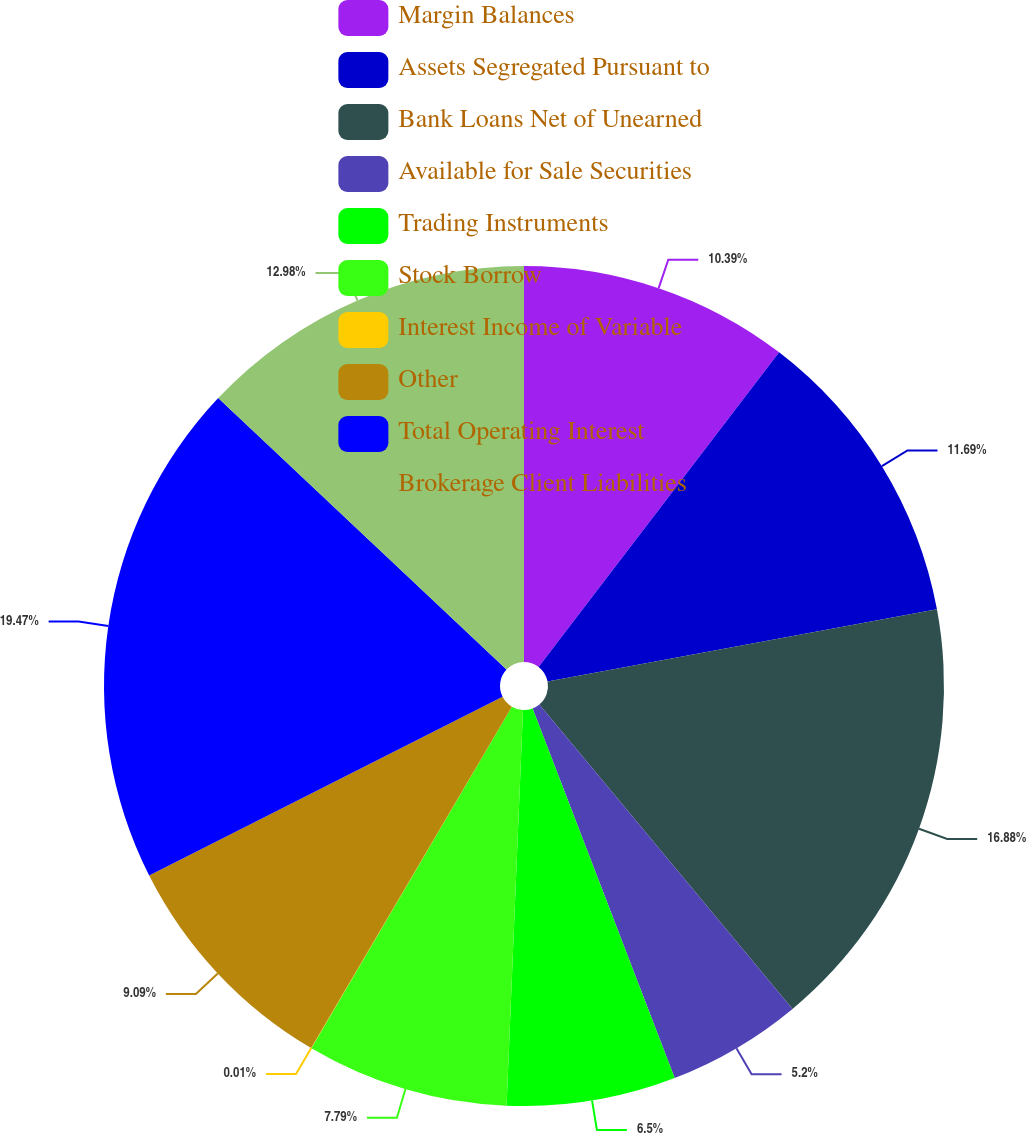Convert chart to OTSL. <chart><loc_0><loc_0><loc_500><loc_500><pie_chart><fcel>Margin Balances<fcel>Assets Segregated Pursuant to<fcel>Bank Loans Net of Unearned<fcel>Available for Sale Securities<fcel>Trading Instruments<fcel>Stock Borrow<fcel>Interest Income of Variable<fcel>Other<fcel>Total Operating Interest<fcel>Brokerage Client Liabilities<nl><fcel>10.39%<fcel>11.69%<fcel>16.88%<fcel>5.2%<fcel>6.5%<fcel>7.79%<fcel>0.01%<fcel>9.09%<fcel>19.47%<fcel>12.98%<nl></chart> 